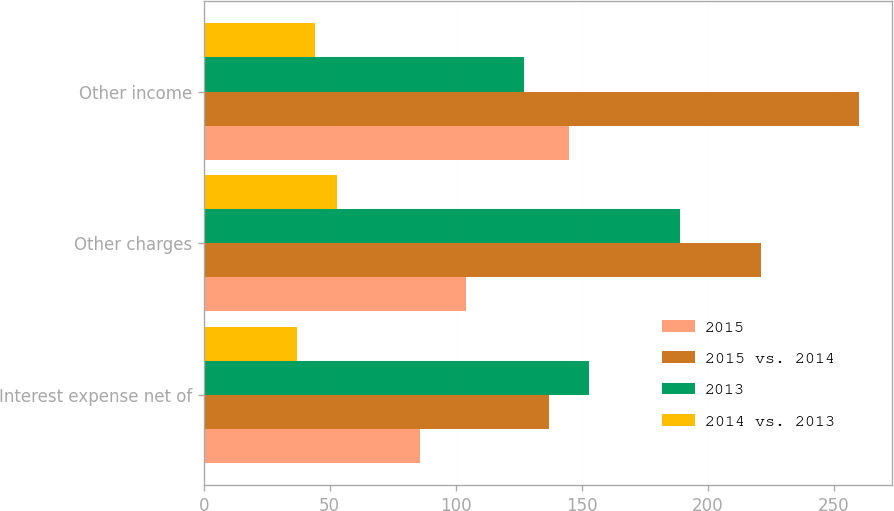Convert chart. <chart><loc_0><loc_0><loc_500><loc_500><stacked_bar_chart><ecel><fcel>Interest expense net of<fcel>Other charges<fcel>Other income<nl><fcel>2015<fcel>86<fcel>104<fcel>145<nl><fcel>2015 vs. 2014<fcel>137<fcel>221<fcel>260<nl><fcel>2013<fcel>153<fcel>189<fcel>127<nl><fcel>2014 vs. 2013<fcel>37.2<fcel>52.9<fcel>44.2<nl></chart> 